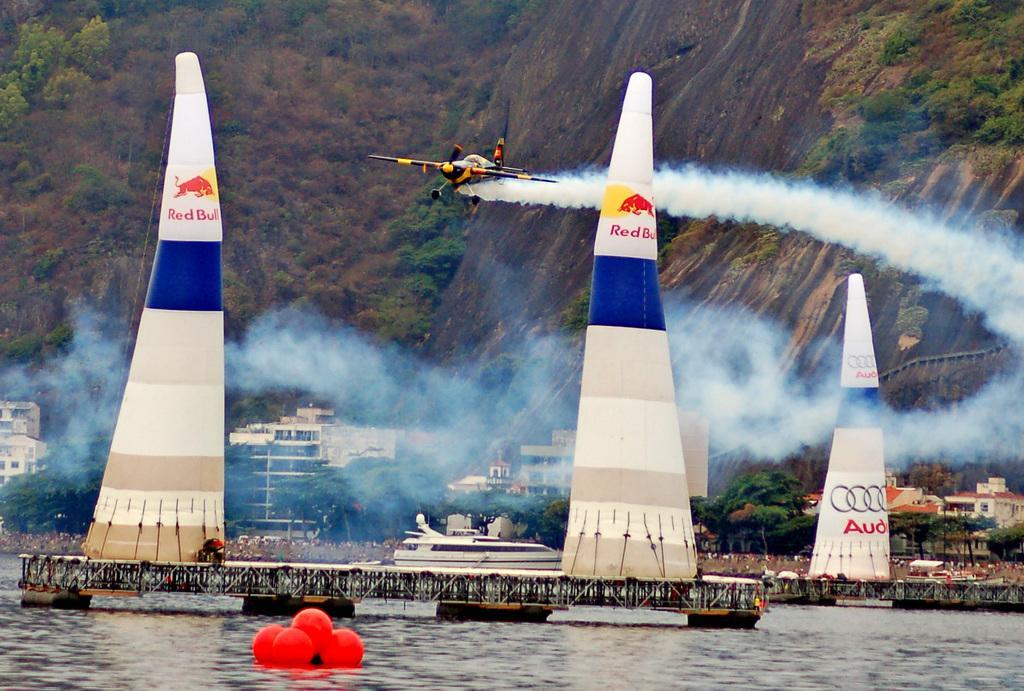How would you summarize this image in a sentence or two? At the bottom of the image we can see water, above the water we can see some boats. Behind the boats we can see some trees and buildings. At the top of the image we can see hills and trees. In the middle of the image we can see a plane. 